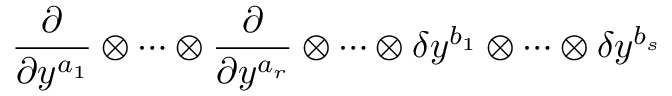<formula> <loc_0><loc_0><loc_500><loc_500>\frac { \partial } \partial y ^ { a _ { 1 } } } \otimes \cdots \otimes \frac { \partial } \partial y ^ { a _ { r } } } \otimes \cdots \otimes \delta y ^ { b _ { 1 } } \otimes \cdots \otimes \delta y ^ { b _ { s } }</formula> 